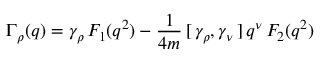<formula> <loc_0><loc_0><loc_500><loc_500>\Gamma _ { \rho } ( q ) = \gamma _ { \rho } \, F _ { 1 } ( q ^ { 2 } ) - \frac { 1 } { 4 m } \, [ \, \gamma _ { \rho } , \gamma _ { \nu } \, ] \, q ^ { \nu } \, F _ { 2 } ( q ^ { 2 } )</formula> 